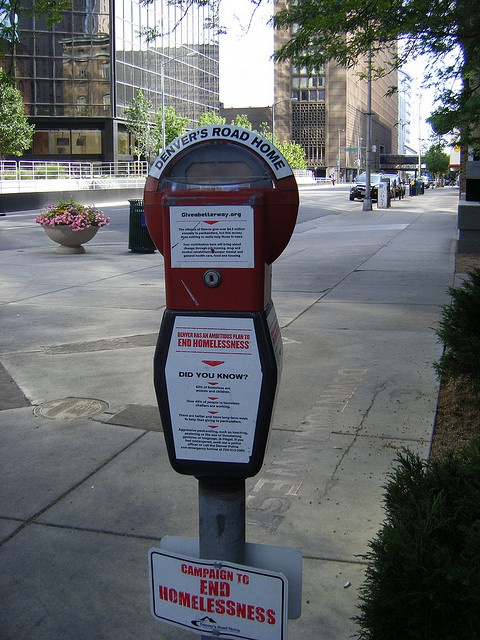Describe the objects in this image and their specific colors. I can see parking meter in teal, black, maroon, and gray tones, potted plant in teal, gray, black, darkgreen, and darkgray tones, car in teal, black, lightgray, lightblue, and darkgray tones, car in teal, lightgray, gray, black, and lightblue tones, and car in teal, black, gray, white, and navy tones in this image. 